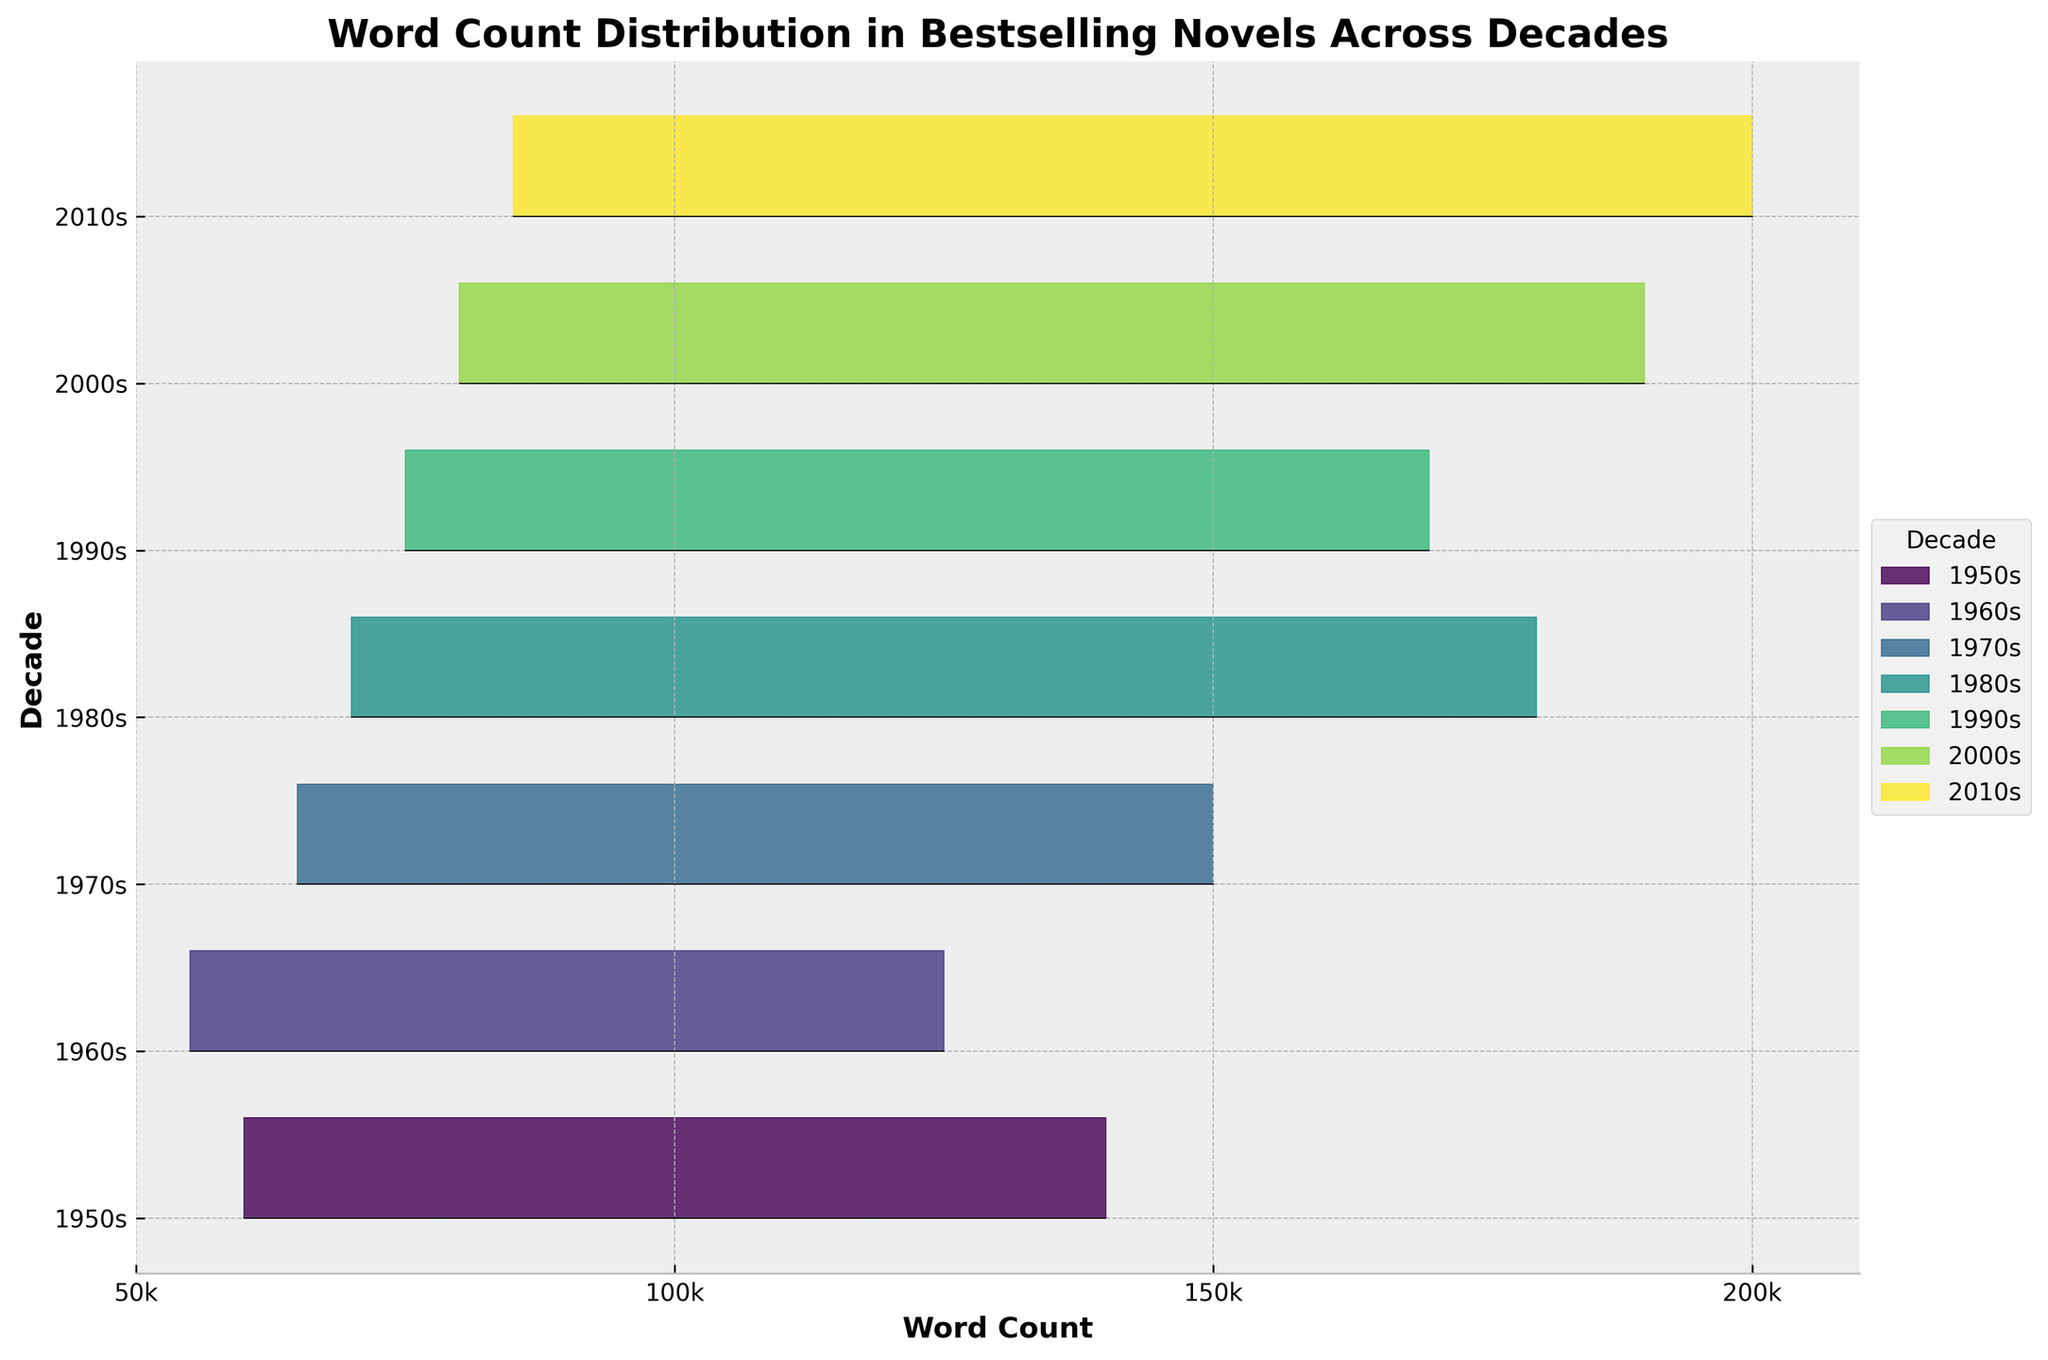What is the title of the plot? The title of the plot is displayed at the top of the figure.
Answer: Word Count Distribution in Bestselling Novels Across Decades Which decade has the highest word count novel shown on the plot? The highest point on the x-axis is at 200,000, which is under the 2010s ridgeline.
Answer: 2010s How many decades are represented in the plot? Each ridgeline corresponds to a decade, and they are labeled on the y-axis. Count the number of unique labels.
Answer: 6 Which decade shows the broadest range in word counts? The broadest range is indicated by the widest spread along the x-axis. Compare the x-axis spans of each ridgeline.
Answer: 2010s Between which two decades is there the greatest shift in the average word count? Estimate the average position of the peaks for each decade’s ridgeline and identify the largest difference between adjacent decades.
Answer: 1990s to 2000s Which decade has the smallest average word count? Find the decade whose ridgeline peak is closest to the left side of the x-axis.
Answer: 1960s What can you infer about the trend in word counts over the decades? Observe the general progression of the word counts along the x-axis from the 1950s to the 2010s.
Answer: Word counts generally increase over time Are there any decades where the word counts appear to be tightly grouped? Look for decades where the ridgeline is closely clustered, indicating lesser variability in word counts.
Answer: 1950s Which decade seems to have the most variability in word counts? Identify the decade with the broadest and possibly the most uneven spread of word counts along the x-axis.
Answer: 2000s Is there any decade where the novel word counts do not exceed 100,000 words? Check each ridgeline to see if it crosses the x-axis mark at 100,000 words.
Answer: 1960s 